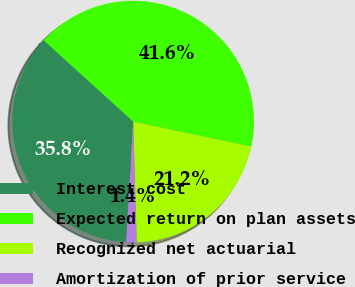Convert chart to OTSL. <chart><loc_0><loc_0><loc_500><loc_500><pie_chart><fcel>Interest cost<fcel>Expected return on plan assets<fcel>Recognized net actuarial<fcel>Amortization of prior service<nl><fcel>35.82%<fcel>41.58%<fcel>21.22%<fcel>1.39%<nl></chart> 